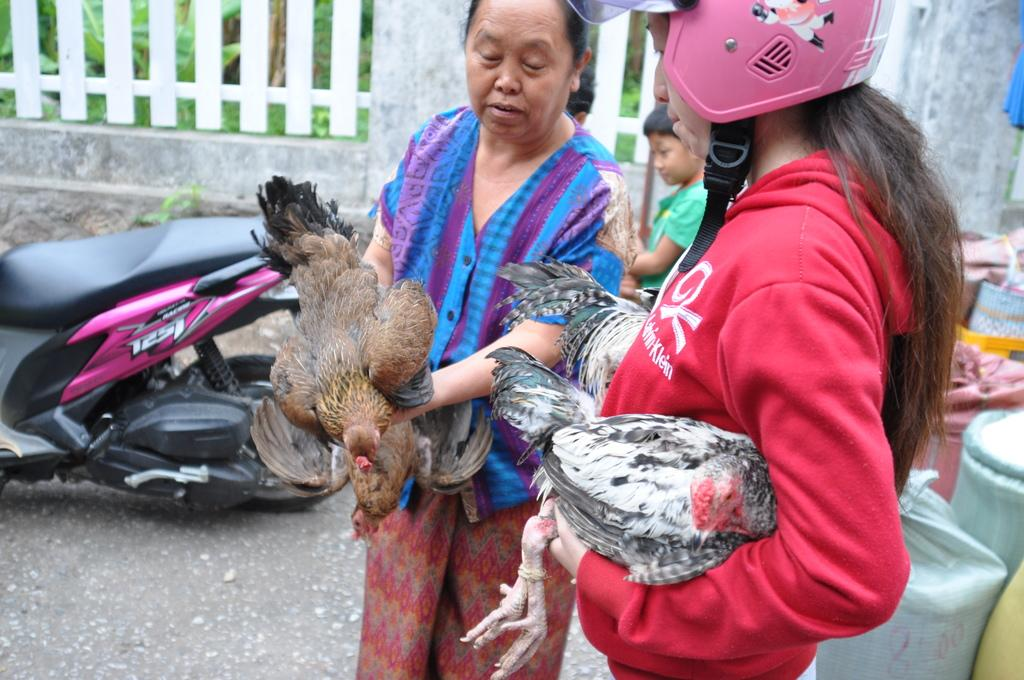How many people are present in the image? There are two people in the image. What are the two people doing? The two people are holding hands. What can be seen in the background of the image? There is a scooter, people standing, bags, and a railing in the background of the image. Can you see any ghosts in the image? No, there are no ghosts present in the image. What type of request is being made by the people in the image? There is no indication of a request being made in the image; the two people are simply holding hands. 